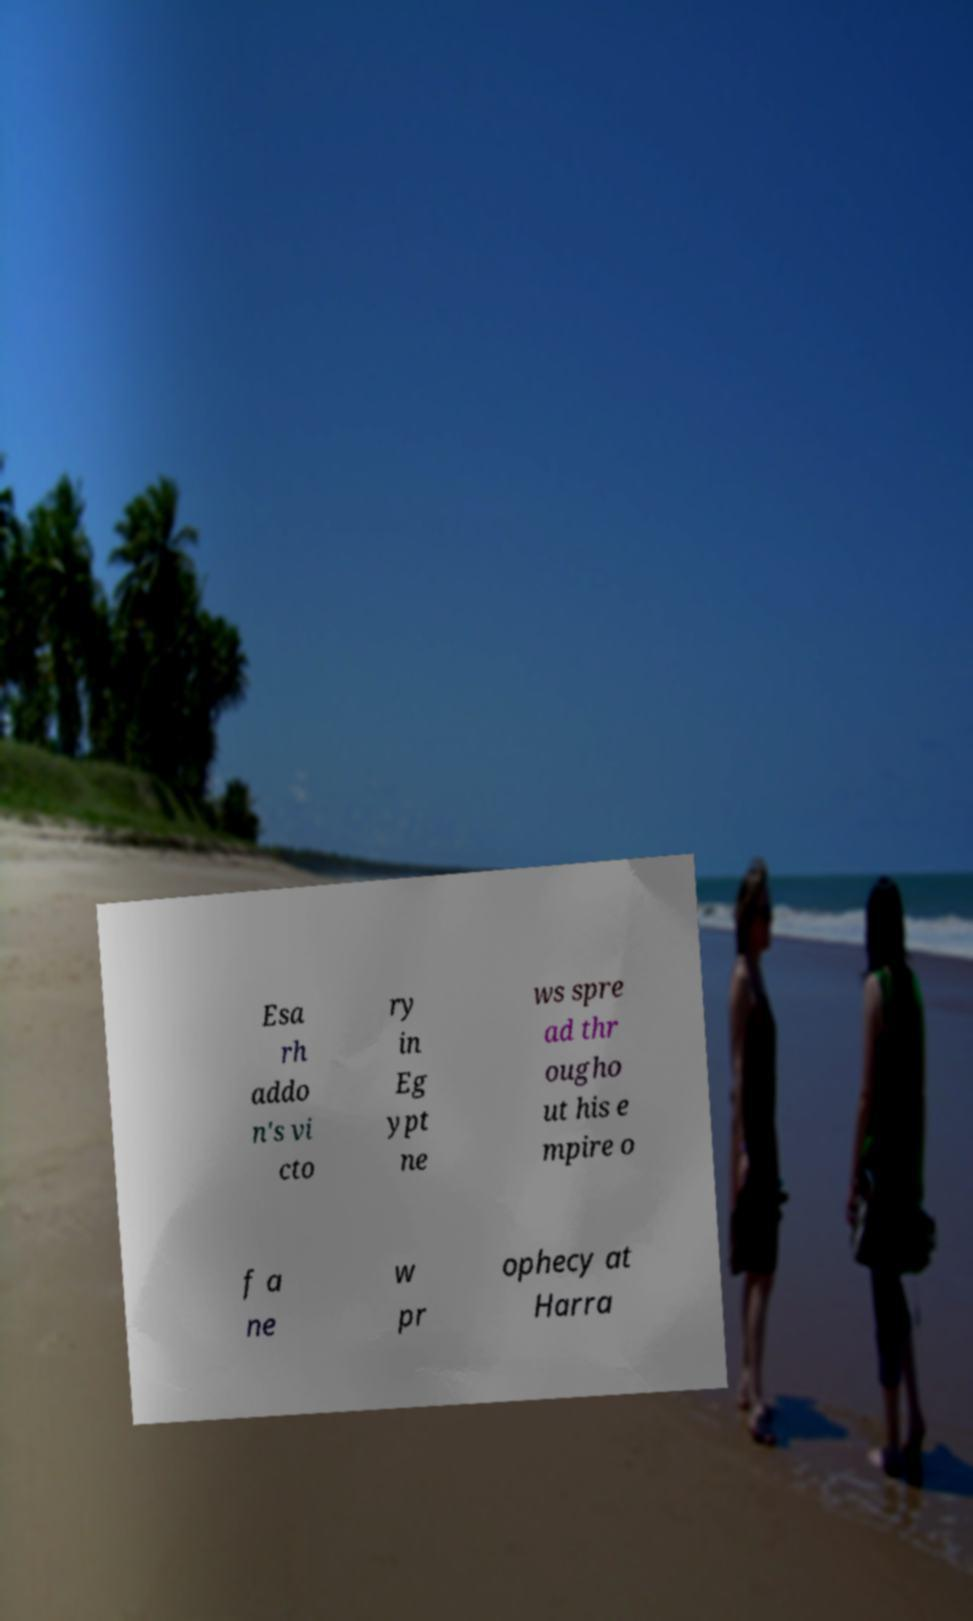Could you extract and type out the text from this image? Esa rh addo n's vi cto ry in Eg ypt ne ws spre ad thr ougho ut his e mpire o f a ne w pr ophecy at Harra 